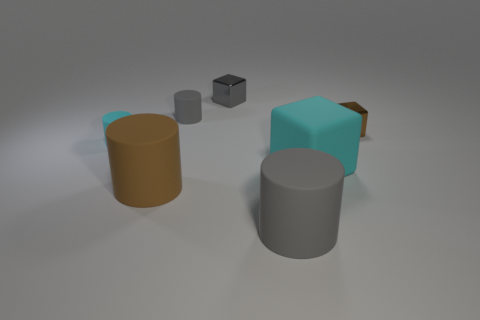What is the size of the cylinder that is the same color as the big block?
Provide a short and direct response. Small. There is a metallic thing that is to the left of the large cyan matte thing; what color is it?
Ensure brevity in your answer.  Gray. What number of rubber things are either cyan things or green things?
Your response must be concise. 2. What shape is the small thing that is the same color as the large block?
Offer a terse response. Cylinder. What number of red rubber cylinders are the same size as the brown metal object?
Offer a very short reply. 0. What color is the object that is on the left side of the small gray cylinder and in front of the large cyan matte thing?
Make the answer very short. Brown. What number of objects are tiny blue cylinders or large cyan cubes?
Offer a terse response. 1. How many big objects are either gray cylinders or blocks?
Your response must be concise. 2. There is a block that is both to the left of the small brown object and in front of the gray cube; how big is it?
Provide a short and direct response. Large. There is a big matte thing that is to the left of the large gray cylinder; does it have the same color as the tiny cube that is in front of the tiny gray rubber cylinder?
Your answer should be compact. Yes. 